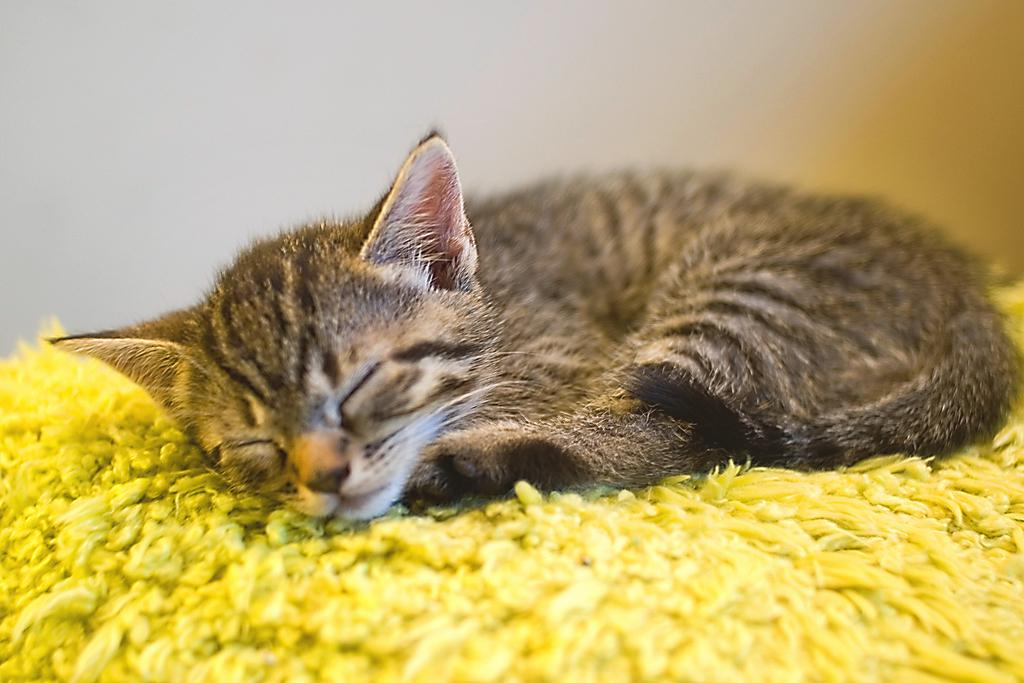What type of animal is present in the image? There is a cat in the image. What is the cat doing in the image? The cat is lying on a mat. What can be seen in the background of the image? There is a wall in the background of the image. What type of quilt is the cat using to cover itself in the image? There is no quilt present in the image; the cat is lying on a mat. Can you see any dirt on the cat in the image? There is no indication of dirt on the cat in the image. 